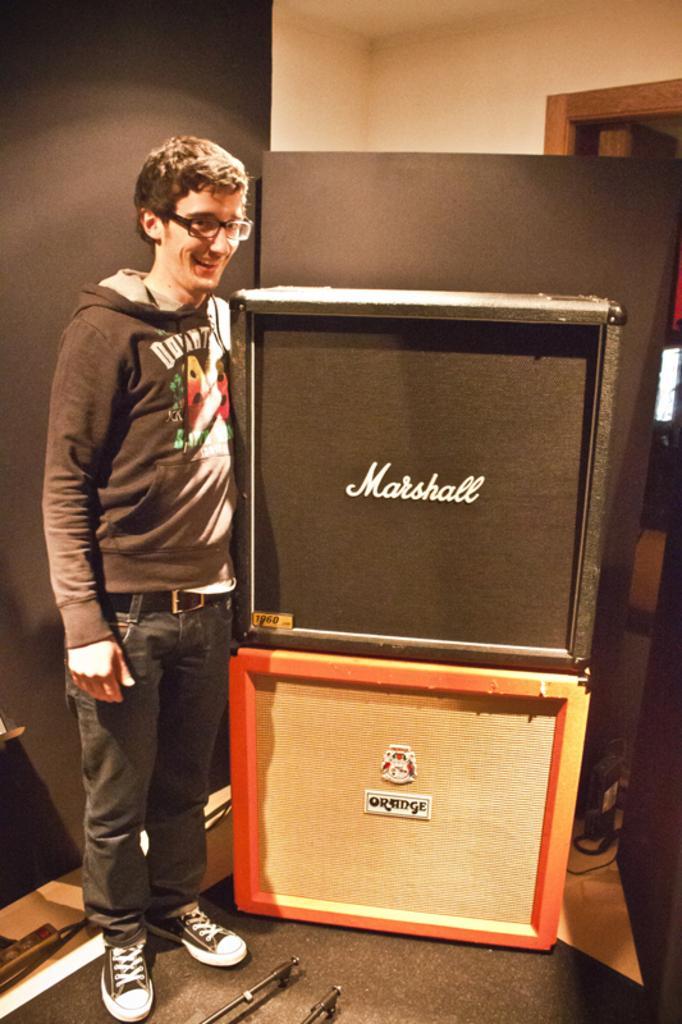Can you describe this image briefly? In this image we can see a man standing in a room and there are boxes beside the man. 